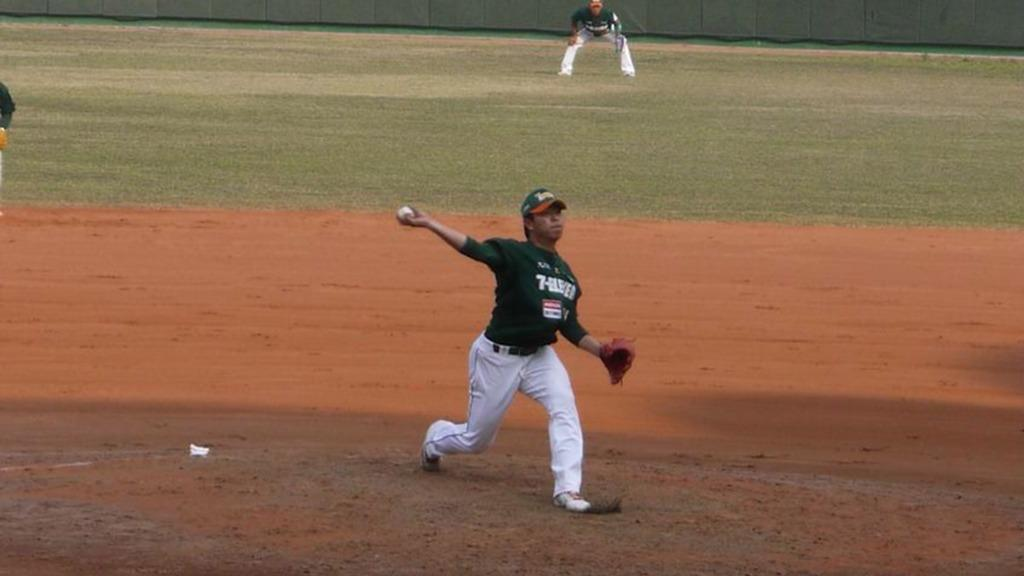What are the people in the image doing? The people in the image are playing a game. Where is the game being played? The game is being played on a ground. Can you describe the man holding a ball in the image? The man is holding a ball and wearing a cap. What type of secretary can be seen in the image? There is no secretary present in the image; it features people playing a game on a ground. 